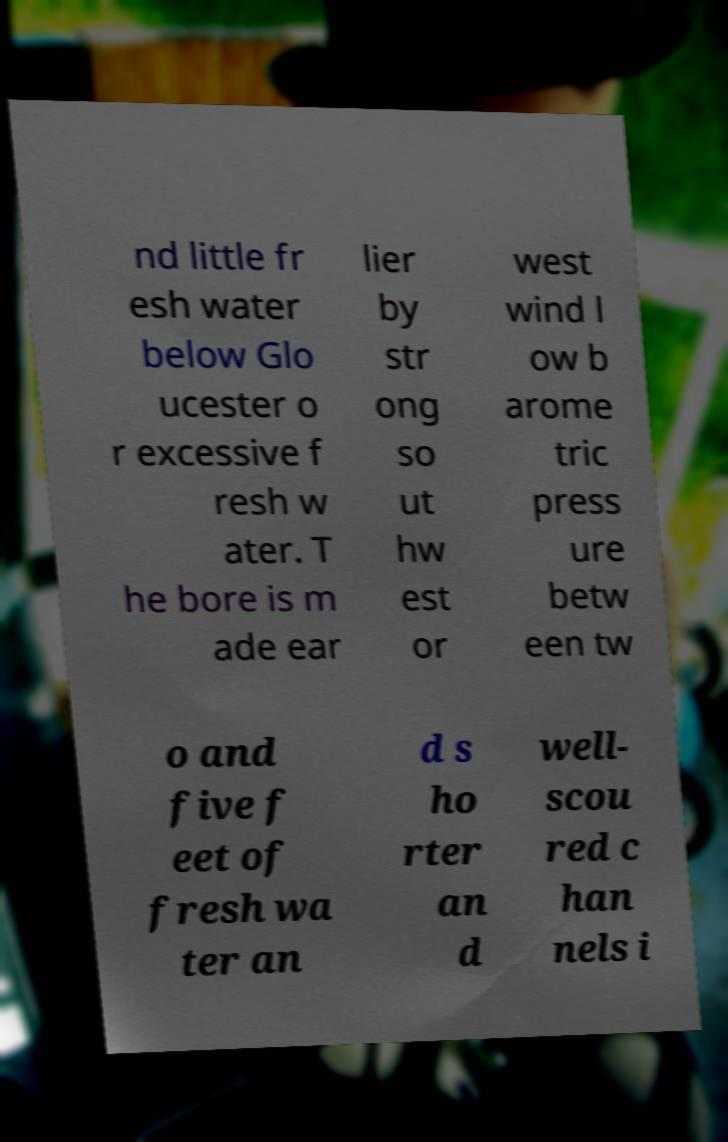There's text embedded in this image that I need extracted. Can you transcribe it verbatim? nd little fr esh water below Glo ucester o r excessive f resh w ater. T he bore is m ade ear lier by str ong so ut hw est or west wind l ow b arome tric press ure betw een tw o and five f eet of fresh wa ter an d s ho rter an d well- scou red c han nels i 